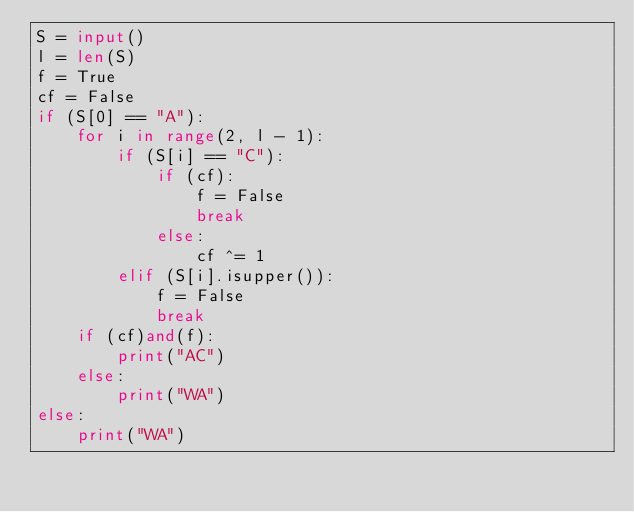Convert code to text. <code><loc_0><loc_0><loc_500><loc_500><_Python_>S = input()
l = len(S)
f = True
cf = False
if (S[0] == "A"):
    for i in range(2, l - 1):
        if (S[i] == "C"):
            if (cf):
                f = False
                break
            else:
                cf ^= 1
        elif (S[i].isupper()):
            f = False
            break
    if (cf)and(f):
        print("AC")
    else:
        print("WA")
else:
    print("WA")
</code> 